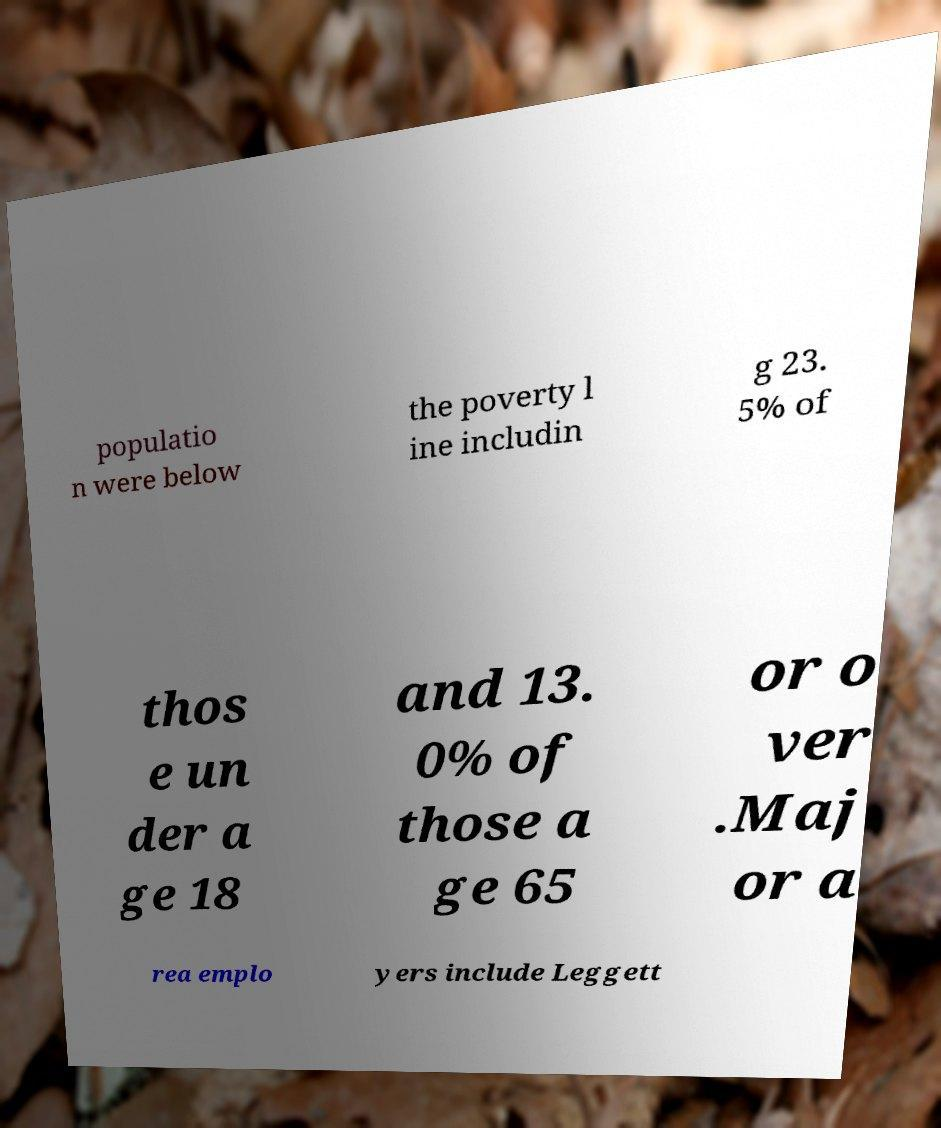Can you read and provide the text displayed in the image?This photo seems to have some interesting text. Can you extract and type it out for me? populatio n were below the poverty l ine includin g 23. 5% of thos e un der a ge 18 and 13. 0% of those a ge 65 or o ver .Maj or a rea emplo yers include Leggett 